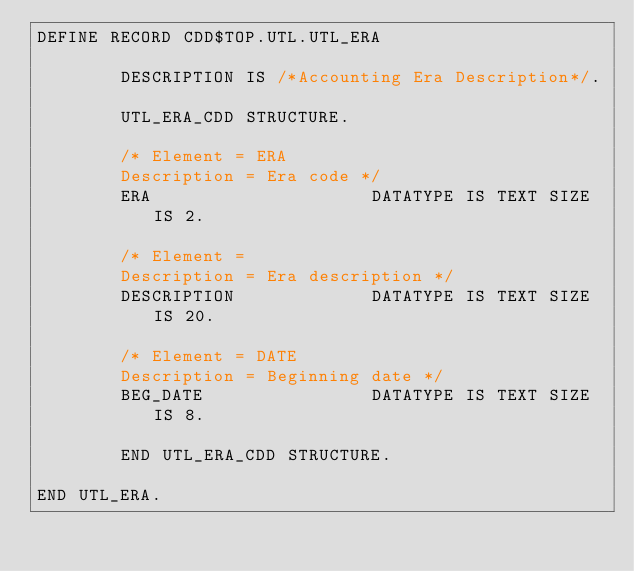<code> <loc_0><loc_0><loc_500><loc_500><_SQL_>DEFINE RECORD CDD$TOP.UTL.UTL_ERA

        DESCRIPTION IS /*Accounting Era Description*/.

        UTL_ERA_CDD STRUCTURE.

        /* Element = ERA
        Description = Era code */
        ERA                     DATATYPE IS TEXT SIZE IS 2.

        /* Element =
        Description = Era description */
        DESCRIPTION             DATATYPE IS TEXT SIZE IS 20.

        /* Element = DATE
        Description = Beginning date */
        BEG_DATE                DATATYPE IS TEXT SIZE IS 8.

        END UTL_ERA_CDD STRUCTURE.

END UTL_ERA.
</code> 